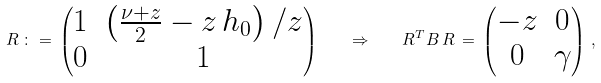<formula> <loc_0><loc_0><loc_500><loc_500>R \, \colon = \, \begin{pmatrix} 1 & \left ( \frac { \nu + z } { 2 } - z \, h _ { 0 } \right ) / z \\ 0 & 1 \end{pmatrix} \quad \Rightarrow \quad R ^ { T } B \, R \, = \, \begin{pmatrix} - z & 0 \\ 0 & \gamma \end{pmatrix} \, ,</formula> 